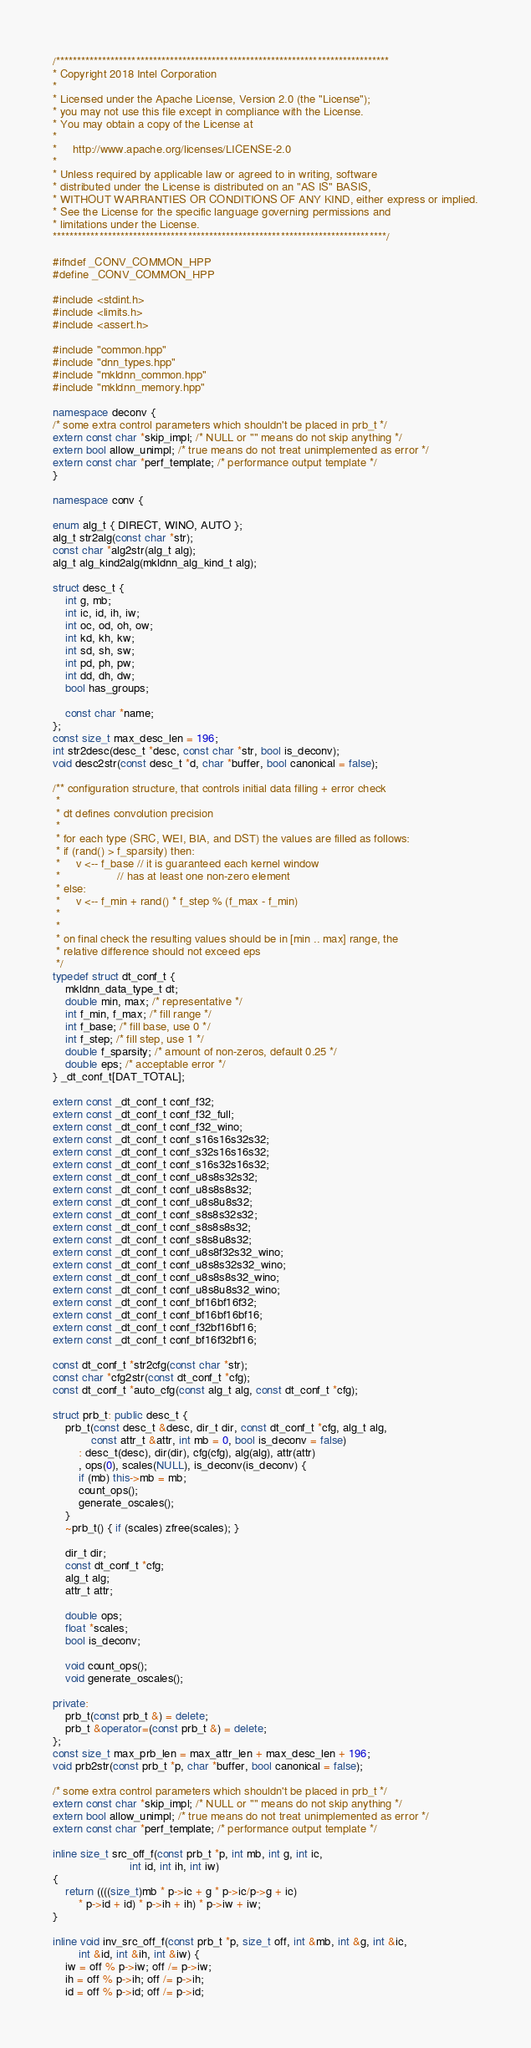<code> <loc_0><loc_0><loc_500><loc_500><_C++_>/*******************************************************************************
* Copyright 2018 Intel Corporation
*
* Licensed under the Apache License, Version 2.0 (the "License");
* you may not use this file except in compliance with the License.
* You may obtain a copy of the License at
*
*     http://www.apache.org/licenses/LICENSE-2.0
*
* Unless required by applicable law or agreed to in writing, software
* distributed under the License is distributed on an "AS IS" BASIS,
* WITHOUT WARRANTIES OR CONDITIONS OF ANY KIND, either express or implied.
* See the License for the specific language governing permissions and
* limitations under the License.
*******************************************************************************/

#ifndef _CONV_COMMON_HPP
#define _CONV_COMMON_HPP

#include <stdint.h>
#include <limits.h>
#include <assert.h>

#include "common.hpp"
#include "dnn_types.hpp"
#include "mkldnn_common.hpp"
#include "mkldnn_memory.hpp"

namespace deconv {
/* some extra control parameters which shouldn't be placed in prb_t */
extern const char *skip_impl; /* NULL or "" means do not skip anything */
extern bool allow_unimpl; /* true means do not treat unimplemented as error */
extern const char *perf_template; /* performance output template */
}

namespace conv {

enum alg_t { DIRECT, WINO, AUTO };
alg_t str2alg(const char *str);
const char *alg2str(alg_t alg);
alg_t alg_kind2alg(mkldnn_alg_kind_t alg);

struct desc_t {
    int g, mb;
    int ic, id, ih, iw;
    int oc, od, oh, ow;
    int kd, kh, kw;
    int sd, sh, sw;
    int pd, ph, pw;
    int dd, dh, dw;
    bool has_groups;

    const char *name;
};
const size_t max_desc_len = 196;
int str2desc(desc_t *desc, const char *str, bool is_deconv);
void desc2str(const desc_t *d, char *buffer, bool canonical = false);

/** configuration structure, that controls initial data filling + error check
 *
 * dt defines convolution precision
 *
 * for each type (SRC, WEI, BIA, and DST) the values are filled as follows:
 * if (rand() > f_sparsity) then:
 *     v <-- f_base // it is guaranteed each kernel window
 *                  // has at least one non-zero element
 * else:
 *     v <-- f_min + rand() * f_step % (f_max - f_min)
 *
 *
 * on final check the resulting values should be in [min .. max] range, the
 * relative difference should not exceed eps
 */
typedef struct dt_conf_t {
    mkldnn_data_type_t dt;
    double min, max; /* representative */
    int f_min, f_max; /* fill range */
    int f_base; /* fill base, use 0 */
    int f_step; /* fill step, use 1 */
    double f_sparsity; /* amount of non-zeros, default 0.25 */
    double eps; /* acceptable error */
} _dt_conf_t[DAT_TOTAL];

extern const _dt_conf_t conf_f32;
extern const _dt_conf_t conf_f32_full;
extern const _dt_conf_t conf_f32_wino;
extern const _dt_conf_t conf_s16s16s32s32;
extern const _dt_conf_t conf_s32s16s16s32;
extern const _dt_conf_t conf_s16s32s16s32;
extern const _dt_conf_t conf_u8s8s32s32;
extern const _dt_conf_t conf_u8s8s8s32;
extern const _dt_conf_t conf_u8s8u8s32;
extern const _dt_conf_t conf_s8s8s32s32;
extern const _dt_conf_t conf_s8s8s8s32;
extern const _dt_conf_t conf_s8s8u8s32;
extern const _dt_conf_t conf_u8s8f32s32_wino;
extern const _dt_conf_t conf_u8s8s32s32_wino;
extern const _dt_conf_t conf_u8s8s8s32_wino;
extern const _dt_conf_t conf_u8s8u8s32_wino;
extern const _dt_conf_t conf_bf16bf16f32;
extern const _dt_conf_t conf_bf16bf16bf16;
extern const _dt_conf_t conf_f32bf16bf16;
extern const _dt_conf_t conf_bf16f32bf16;

const dt_conf_t *str2cfg(const char *str);
const char *cfg2str(const dt_conf_t *cfg);
const dt_conf_t *auto_cfg(const alg_t alg, const dt_conf_t *cfg);

struct prb_t: public desc_t {
    prb_t(const desc_t &desc, dir_t dir, const dt_conf_t *cfg, alg_t alg,
            const attr_t &attr, int mb = 0, bool is_deconv = false)
        : desc_t(desc), dir(dir), cfg(cfg), alg(alg), attr(attr)
        , ops(0), scales(NULL), is_deconv(is_deconv) {
        if (mb) this->mb = mb;
        count_ops();
        generate_oscales();
    }
    ~prb_t() { if (scales) zfree(scales); }

    dir_t dir;
    const dt_conf_t *cfg;
    alg_t alg;
    attr_t attr;

    double ops;
    float *scales;
    bool is_deconv;

    void count_ops();
    void generate_oscales();

private:
    prb_t(const prb_t &) = delete;
    prb_t &operator=(const prb_t &) = delete;
};
const size_t max_prb_len = max_attr_len + max_desc_len + 196;
void prb2str(const prb_t *p, char *buffer, bool canonical = false);

/* some extra control parameters which shouldn't be placed in prb_t */
extern const char *skip_impl; /* NULL or "" means do not skip anything */
extern bool allow_unimpl; /* true means do not treat unimplemented as error */
extern const char *perf_template; /* performance output template */

inline size_t src_off_f(const prb_t *p, int mb, int g, int ic,
                        int id, int ih, int iw)
{
    return ((((size_t)mb * p->ic + g * p->ic/p->g + ic)
        * p->id + id) * p->ih + ih) * p->iw + iw;
}

inline void inv_src_off_f(const prb_t *p, size_t off, int &mb, int &g, int &ic,
        int &id, int &ih, int &iw) {
    iw = off % p->iw; off /= p->iw;
    ih = off % p->ih; off /= p->ih;
    id = off % p->id; off /= p->id;</code> 